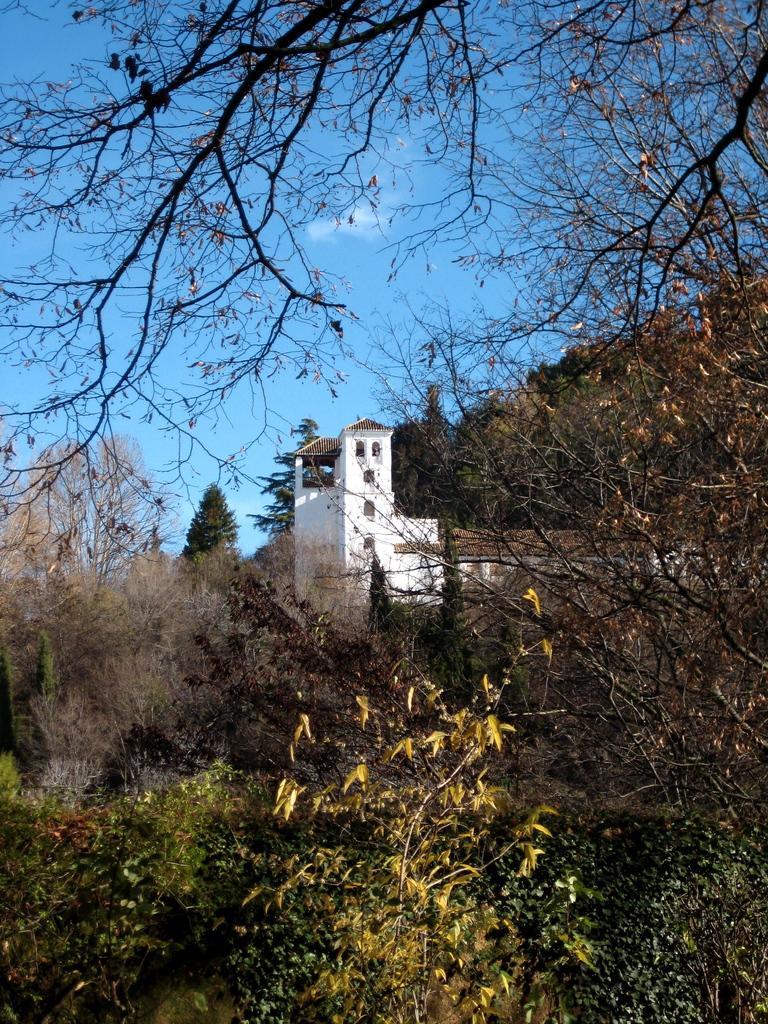Could you give a brief overview of what you see in this image? This picture shows blue sky and a house surrounded by trees 